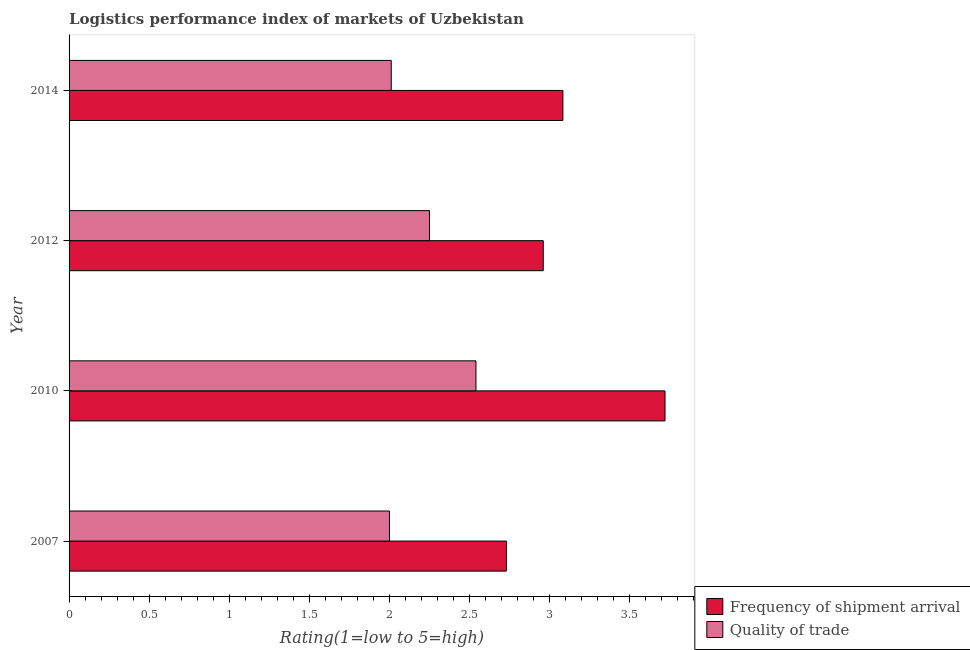How many groups of bars are there?
Your answer should be very brief. 4. Are the number of bars per tick equal to the number of legend labels?
Make the answer very short. Yes. How many bars are there on the 3rd tick from the top?
Give a very brief answer. 2. How many bars are there on the 3rd tick from the bottom?
Make the answer very short. 2. In how many cases, is the number of bars for a given year not equal to the number of legend labels?
Provide a short and direct response. 0. What is the lpi quality of trade in 2007?
Your answer should be very brief. 2. Across all years, what is the maximum lpi of frequency of shipment arrival?
Provide a short and direct response. 3.72. Across all years, what is the minimum lpi of frequency of shipment arrival?
Offer a very short reply. 2.73. What is the total lpi quality of trade in the graph?
Your response must be concise. 8.8. What is the difference between the lpi quality of trade in 2007 and that in 2014?
Ensure brevity in your answer.  -0.01. In the year 2010, what is the difference between the lpi of frequency of shipment arrival and lpi quality of trade?
Give a very brief answer. 1.18. What is the ratio of the lpi of frequency of shipment arrival in 2007 to that in 2014?
Give a very brief answer. 0.89. What is the difference between the highest and the second highest lpi quality of trade?
Your answer should be compact. 0.29. What is the difference between the highest and the lowest lpi of frequency of shipment arrival?
Make the answer very short. 0.99. In how many years, is the lpi of frequency of shipment arrival greater than the average lpi of frequency of shipment arrival taken over all years?
Offer a terse response. 1. What does the 2nd bar from the top in 2012 represents?
Offer a very short reply. Frequency of shipment arrival. What does the 2nd bar from the bottom in 2007 represents?
Keep it short and to the point. Quality of trade. What is the difference between two consecutive major ticks on the X-axis?
Provide a short and direct response. 0.5. Does the graph contain grids?
Your answer should be very brief. No. Where does the legend appear in the graph?
Give a very brief answer. Bottom right. How many legend labels are there?
Give a very brief answer. 2. What is the title of the graph?
Your answer should be compact. Logistics performance index of markets of Uzbekistan. What is the label or title of the X-axis?
Your answer should be compact. Rating(1=low to 5=high). What is the label or title of the Y-axis?
Keep it short and to the point. Year. What is the Rating(1=low to 5=high) in Frequency of shipment arrival in 2007?
Ensure brevity in your answer.  2.73. What is the Rating(1=low to 5=high) in Frequency of shipment arrival in 2010?
Provide a short and direct response. 3.72. What is the Rating(1=low to 5=high) of Quality of trade in 2010?
Make the answer very short. 2.54. What is the Rating(1=low to 5=high) in Frequency of shipment arrival in 2012?
Ensure brevity in your answer.  2.96. What is the Rating(1=low to 5=high) in Quality of trade in 2012?
Your answer should be very brief. 2.25. What is the Rating(1=low to 5=high) of Frequency of shipment arrival in 2014?
Provide a short and direct response. 3.08. What is the Rating(1=low to 5=high) of Quality of trade in 2014?
Provide a short and direct response. 2.01. Across all years, what is the maximum Rating(1=low to 5=high) in Frequency of shipment arrival?
Your answer should be compact. 3.72. Across all years, what is the maximum Rating(1=low to 5=high) of Quality of trade?
Ensure brevity in your answer.  2.54. Across all years, what is the minimum Rating(1=low to 5=high) of Frequency of shipment arrival?
Your response must be concise. 2.73. Across all years, what is the minimum Rating(1=low to 5=high) in Quality of trade?
Make the answer very short. 2. What is the total Rating(1=low to 5=high) in Frequency of shipment arrival in the graph?
Your answer should be compact. 12.49. What is the total Rating(1=low to 5=high) in Quality of trade in the graph?
Offer a very short reply. 8.8. What is the difference between the Rating(1=low to 5=high) of Frequency of shipment arrival in 2007 and that in 2010?
Give a very brief answer. -0.99. What is the difference between the Rating(1=low to 5=high) in Quality of trade in 2007 and that in 2010?
Give a very brief answer. -0.54. What is the difference between the Rating(1=low to 5=high) in Frequency of shipment arrival in 2007 and that in 2012?
Offer a terse response. -0.23. What is the difference between the Rating(1=low to 5=high) of Frequency of shipment arrival in 2007 and that in 2014?
Ensure brevity in your answer.  -0.35. What is the difference between the Rating(1=low to 5=high) of Quality of trade in 2007 and that in 2014?
Offer a terse response. -0.01. What is the difference between the Rating(1=low to 5=high) of Frequency of shipment arrival in 2010 and that in 2012?
Your response must be concise. 0.76. What is the difference between the Rating(1=low to 5=high) of Quality of trade in 2010 and that in 2012?
Ensure brevity in your answer.  0.29. What is the difference between the Rating(1=low to 5=high) of Frequency of shipment arrival in 2010 and that in 2014?
Provide a short and direct response. 0.64. What is the difference between the Rating(1=low to 5=high) of Quality of trade in 2010 and that in 2014?
Provide a succinct answer. 0.53. What is the difference between the Rating(1=low to 5=high) in Frequency of shipment arrival in 2012 and that in 2014?
Your answer should be compact. -0.12. What is the difference between the Rating(1=low to 5=high) of Quality of trade in 2012 and that in 2014?
Provide a succinct answer. 0.24. What is the difference between the Rating(1=low to 5=high) in Frequency of shipment arrival in 2007 and the Rating(1=low to 5=high) in Quality of trade in 2010?
Offer a terse response. 0.19. What is the difference between the Rating(1=low to 5=high) of Frequency of shipment arrival in 2007 and the Rating(1=low to 5=high) of Quality of trade in 2012?
Make the answer very short. 0.48. What is the difference between the Rating(1=low to 5=high) of Frequency of shipment arrival in 2007 and the Rating(1=low to 5=high) of Quality of trade in 2014?
Offer a terse response. 0.72. What is the difference between the Rating(1=low to 5=high) in Frequency of shipment arrival in 2010 and the Rating(1=low to 5=high) in Quality of trade in 2012?
Keep it short and to the point. 1.47. What is the difference between the Rating(1=low to 5=high) of Frequency of shipment arrival in 2010 and the Rating(1=low to 5=high) of Quality of trade in 2014?
Give a very brief answer. 1.71. What is the difference between the Rating(1=low to 5=high) of Frequency of shipment arrival in 2012 and the Rating(1=low to 5=high) of Quality of trade in 2014?
Offer a terse response. 0.95. What is the average Rating(1=low to 5=high) in Frequency of shipment arrival per year?
Your answer should be very brief. 3.12. What is the average Rating(1=low to 5=high) of Quality of trade per year?
Your response must be concise. 2.2. In the year 2007, what is the difference between the Rating(1=low to 5=high) in Frequency of shipment arrival and Rating(1=low to 5=high) in Quality of trade?
Your response must be concise. 0.73. In the year 2010, what is the difference between the Rating(1=low to 5=high) in Frequency of shipment arrival and Rating(1=low to 5=high) in Quality of trade?
Your response must be concise. 1.18. In the year 2012, what is the difference between the Rating(1=low to 5=high) in Frequency of shipment arrival and Rating(1=low to 5=high) in Quality of trade?
Provide a succinct answer. 0.71. In the year 2014, what is the difference between the Rating(1=low to 5=high) of Frequency of shipment arrival and Rating(1=low to 5=high) of Quality of trade?
Your answer should be very brief. 1.07. What is the ratio of the Rating(1=low to 5=high) of Frequency of shipment arrival in 2007 to that in 2010?
Your answer should be compact. 0.73. What is the ratio of the Rating(1=low to 5=high) in Quality of trade in 2007 to that in 2010?
Give a very brief answer. 0.79. What is the ratio of the Rating(1=low to 5=high) of Frequency of shipment arrival in 2007 to that in 2012?
Provide a short and direct response. 0.92. What is the ratio of the Rating(1=low to 5=high) of Quality of trade in 2007 to that in 2012?
Make the answer very short. 0.89. What is the ratio of the Rating(1=low to 5=high) of Frequency of shipment arrival in 2007 to that in 2014?
Give a very brief answer. 0.89. What is the ratio of the Rating(1=low to 5=high) of Quality of trade in 2007 to that in 2014?
Ensure brevity in your answer.  0.99. What is the ratio of the Rating(1=low to 5=high) of Frequency of shipment arrival in 2010 to that in 2012?
Make the answer very short. 1.26. What is the ratio of the Rating(1=low to 5=high) of Quality of trade in 2010 to that in 2012?
Offer a terse response. 1.13. What is the ratio of the Rating(1=low to 5=high) of Frequency of shipment arrival in 2010 to that in 2014?
Provide a short and direct response. 1.21. What is the ratio of the Rating(1=low to 5=high) of Quality of trade in 2010 to that in 2014?
Offer a terse response. 1.26. What is the ratio of the Rating(1=low to 5=high) of Frequency of shipment arrival in 2012 to that in 2014?
Your answer should be compact. 0.96. What is the ratio of the Rating(1=low to 5=high) in Quality of trade in 2012 to that in 2014?
Your answer should be compact. 1.12. What is the difference between the highest and the second highest Rating(1=low to 5=high) of Frequency of shipment arrival?
Provide a short and direct response. 0.64. What is the difference between the highest and the second highest Rating(1=low to 5=high) of Quality of trade?
Offer a terse response. 0.29. What is the difference between the highest and the lowest Rating(1=low to 5=high) in Quality of trade?
Offer a very short reply. 0.54. 